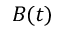<formula> <loc_0><loc_0><loc_500><loc_500>B ( t )</formula> 